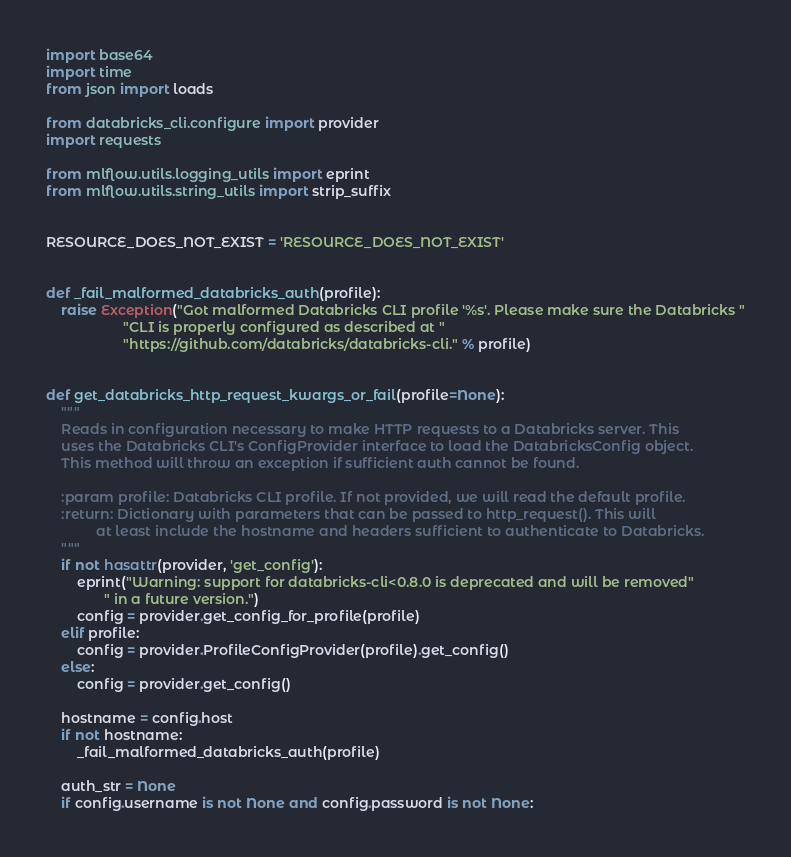Convert code to text. <code><loc_0><loc_0><loc_500><loc_500><_Python_>import base64
import time
from json import loads

from databricks_cli.configure import provider
import requests

from mlflow.utils.logging_utils import eprint
from mlflow.utils.string_utils import strip_suffix


RESOURCE_DOES_NOT_EXIST = 'RESOURCE_DOES_NOT_EXIST'


def _fail_malformed_databricks_auth(profile):
    raise Exception("Got malformed Databricks CLI profile '%s'. Please make sure the Databricks "
                    "CLI is properly configured as described at "
                    "https://github.com/databricks/databricks-cli." % profile)


def get_databricks_http_request_kwargs_or_fail(profile=None):
    """
    Reads in configuration necessary to make HTTP requests to a Databricks server. This
    uses the Databricks CLI's ConfigProvider interface to load the DatabricksConfig object.
    This method will throw an exception if sufficient auth cannot be found.

    :param profile: Databricks CLI profile. If not provided, we will read the default profile.
    :return: Dictionary with parameters that can be passed to http_request(). This will
             at least include the hostname and headers sufficient to authenticate to Databricks.
    """
    if not hasattr(provider, 'get_config'):
        eprint("Warning: support for databricks-cli<0.8.0 is deprecated and will be removed"
               " in a future version.")
        config = provider.get_config_for_profile(profile)
    elif profile:
        config = provider.ProfileConfigProvider(profile).get_config()
    else:
        config = provider.get_config()

    hostname = config.host
    if not hostname:
        _fail_malformed_databricks_auth(profile)

    auth_str = None
    if config.username is not None and config.password is not None:</code> 